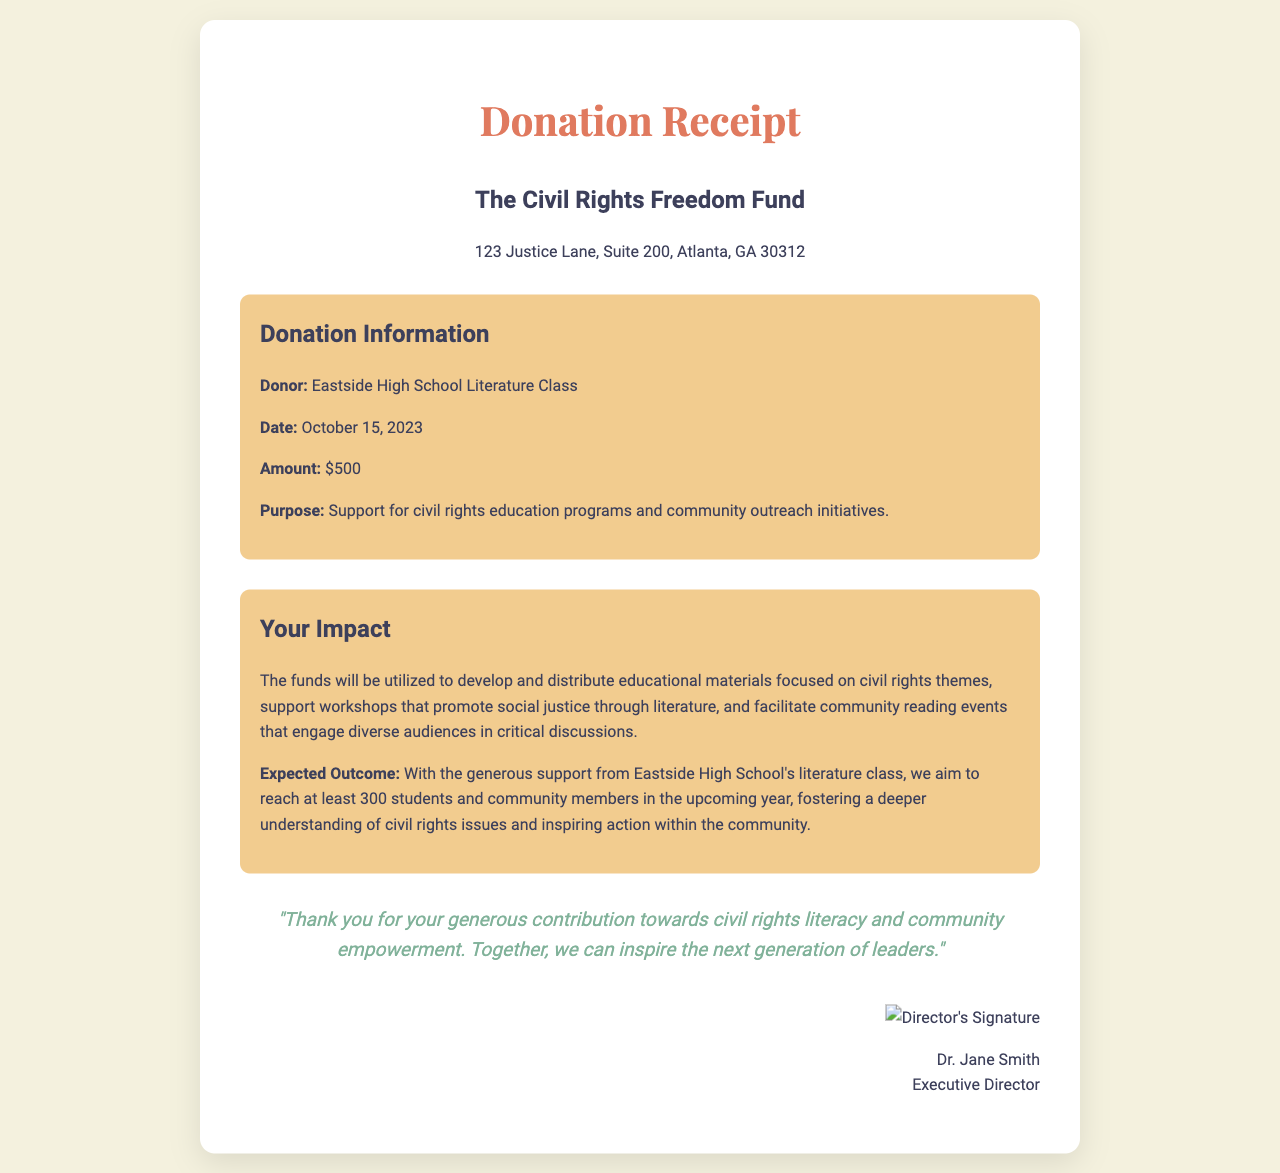What is the name of the organization receiving the donation? The name of the organization, as stated in the document, is prominently displayed at the top.
Answer: The Civil Rights Freedom Fund What is the amount of the donation? The donation amount is clearly mentioned under the donation details section.
Answer: $500 Who made the donation? The document indicates the specific donor in relation to the donation.
Answer: Eastside High School Literature Class What is the purpose of the donation? The purpose of the donation is specified directly after the donation amount.
Answer: Support for civil rights education programs and community outreach initiatives On what date was the donation made? The date of the donation is provided in the donation details section.
Answer: October 15, 2023 What is the expected outcome of the donation? The document outlines the anticipated impact as a measure of engagement with the community.
Answer: Reach at least 300 students and community members Who is the Executive Director of the organization? The document includes the name and title of the individual signing the receipt.
Answer: Dr. Jane Smith What type of educational materials will the funds support? The educational materials mentioned relate to specific themes highlighted in the document.
Answer: Civil rights themes What is one of the activities promoted by the donation? The document provides examples of initiatives that will be facilitated through the donation.
Answer: Community reading events 